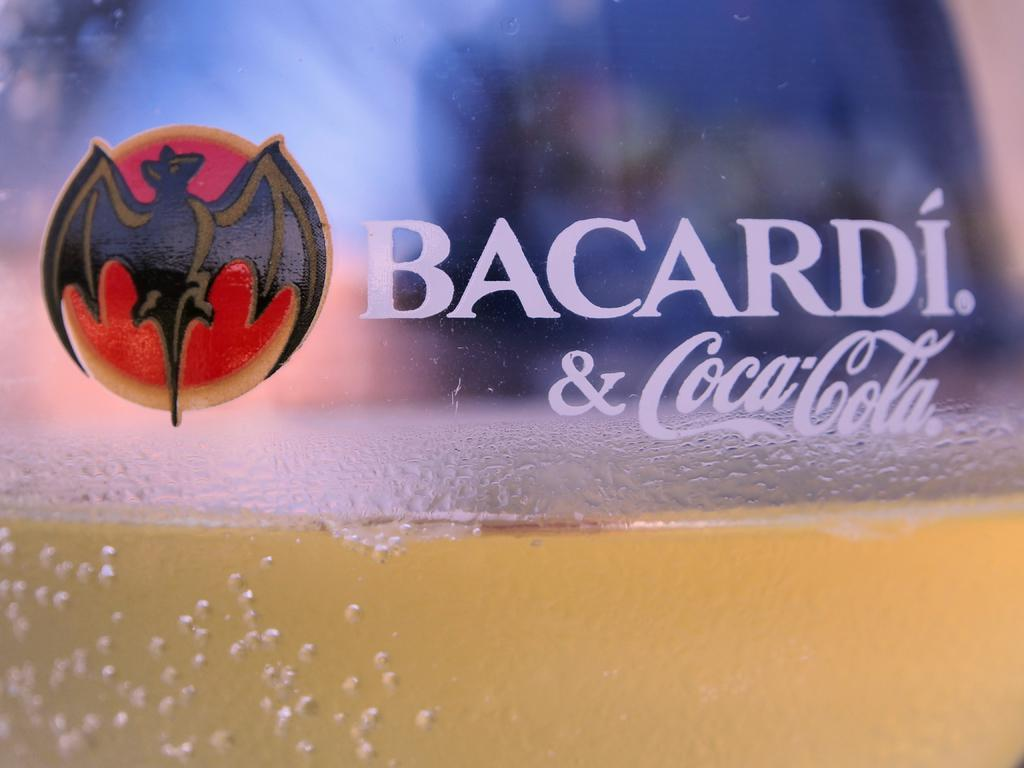<image>
Describe the image concisely. A cup with a Barcardi logo is full of alcohol. 